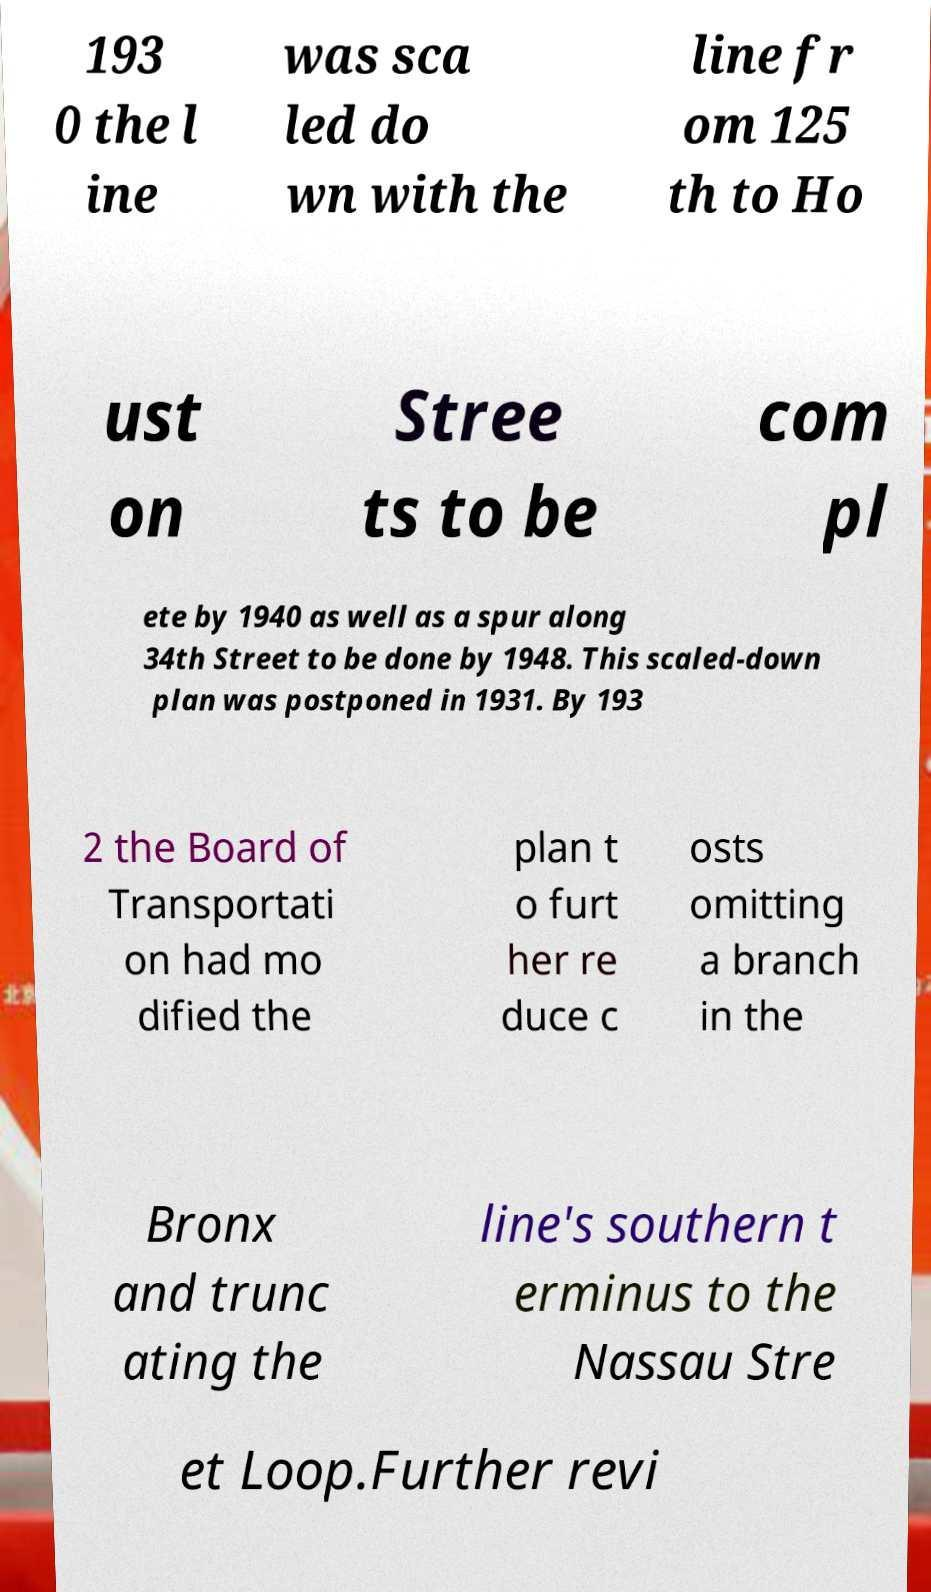Could you assist in decoding the text presented in this image and type it out clearly? 193 0 the l ine was sca led do wn with the line fr om 125 th to Ho ust on Stree ts to be com pl ete by 1940 as well as a spur along 34th Street to be done by 1948. This scaled-down plan was postponed in 1931. By 193 2 the Board of Transportati on had mo dified the plan t o furt her re duce c osts omitting a branch in the Bronx and trunc ating the line's southern t erminus to the Nassau Stre et Loop.Further revi 